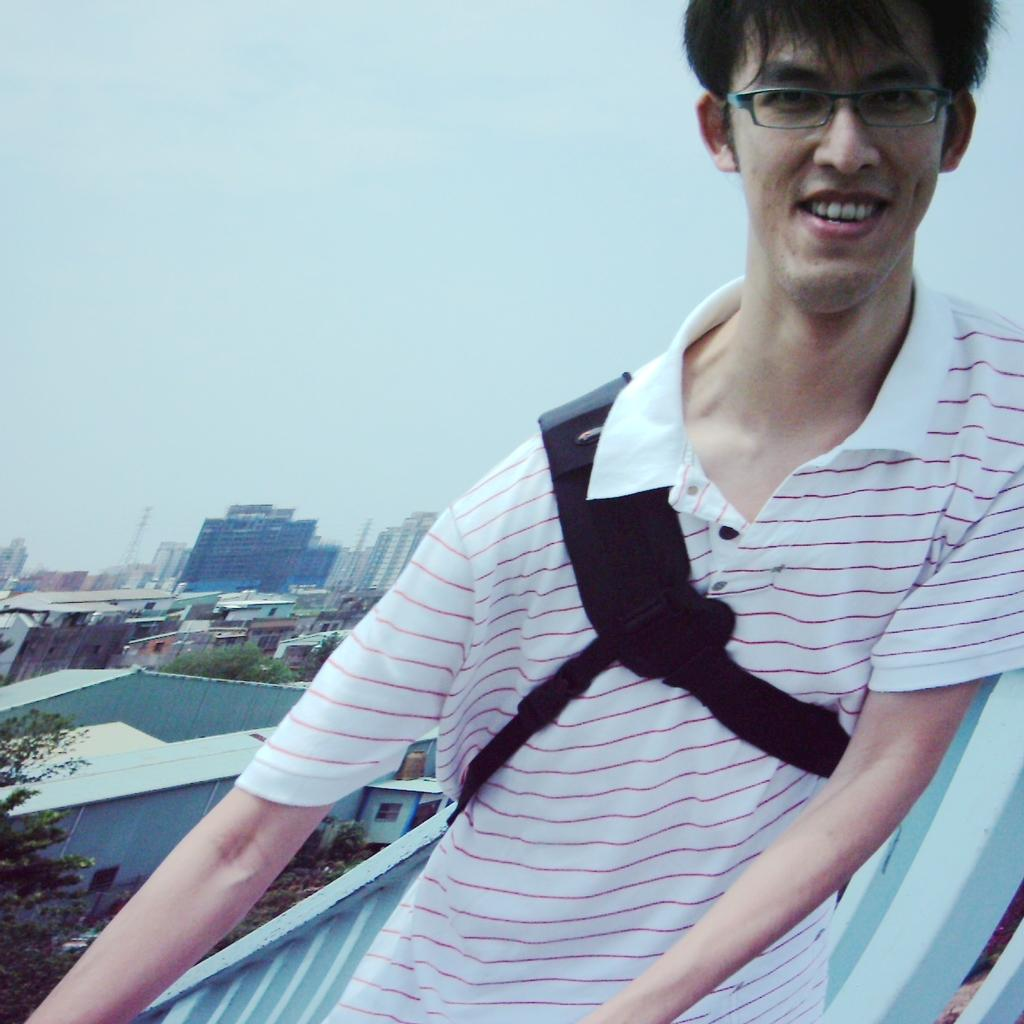What is the man in the image doing? The man is standing beside a barricade. What can be seen in the background of the image? There is a group of buildings, a tower, trees, and the sky visible in the background. How would you describe the sky in the image? The sky appears cloudy in the image. What type of comb is being used to style the man's hair in the image? There is no comb or any reference to hair in the image. 